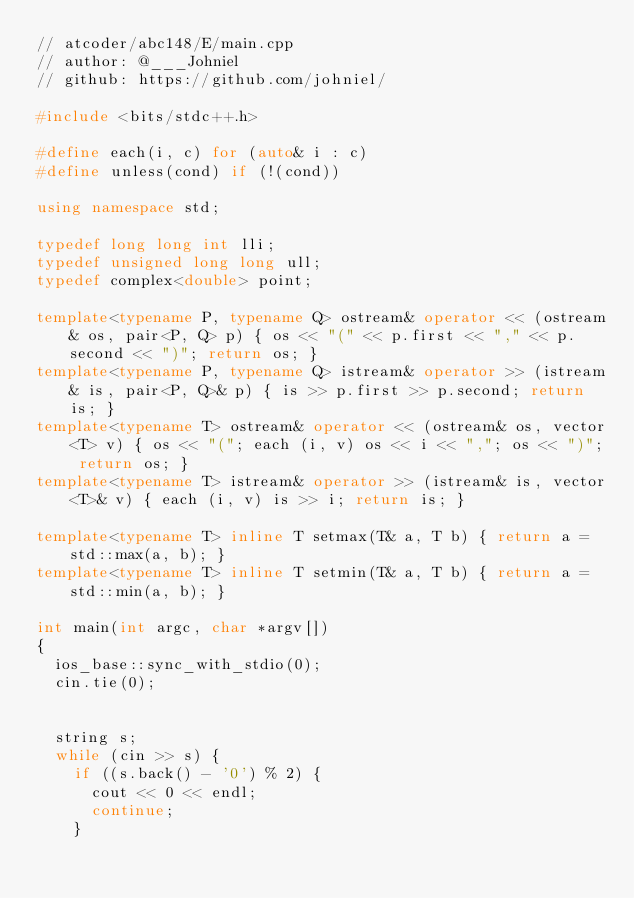<code> <loc_0><loc_0><loc_500><loc_500><_C++_>// atcoder/abc148/E/main.cpp
// author: @___Johniel
// github: https://github.com/johniel/

#include <bits/stdc++.h>

#define each(i, c) for (auto& i : c)
#define unless(cond) if (!(cond))

using namespace std;

typedef long long int lli;
typedef unsigned long long ull;
typedef complex<double> point;

template<typename P, typename Q> ostream& operator << (ostream& os, pair<P, Q> p) { os << "(" << p.first << "," << p.second << ")"; return os; }
template<typename P, typename Q> istream& operator >> (istream& is, pair<P, Q>& p) { is >> p.first >> p.second; return is; }
template<typename T> ostream& operator << (ostream& os, vector<T> v) { os << "("; each (i, v) os << i << ","; os << ")"; return os; }
template<typename T> istream& operator >> (istream& is, vector<T>& v) { each (i, v) is >> i; return is; }

template<typename T> inline T setmax(T& a, T b) { return a = std::max(a, b); }
template<typename T> inline T setmin(T& a, T b) { return a = std::min(a, b); }

int main(int argc, char *argv[])
{
  ios_base::sync_with_stdio(0);
  cin.tie(0);


  string s;
  while (cin >> s) {
    if ((s.back() - '0') % 2) {
      cout << 0 << endl;
      continue;
    }
</code> 